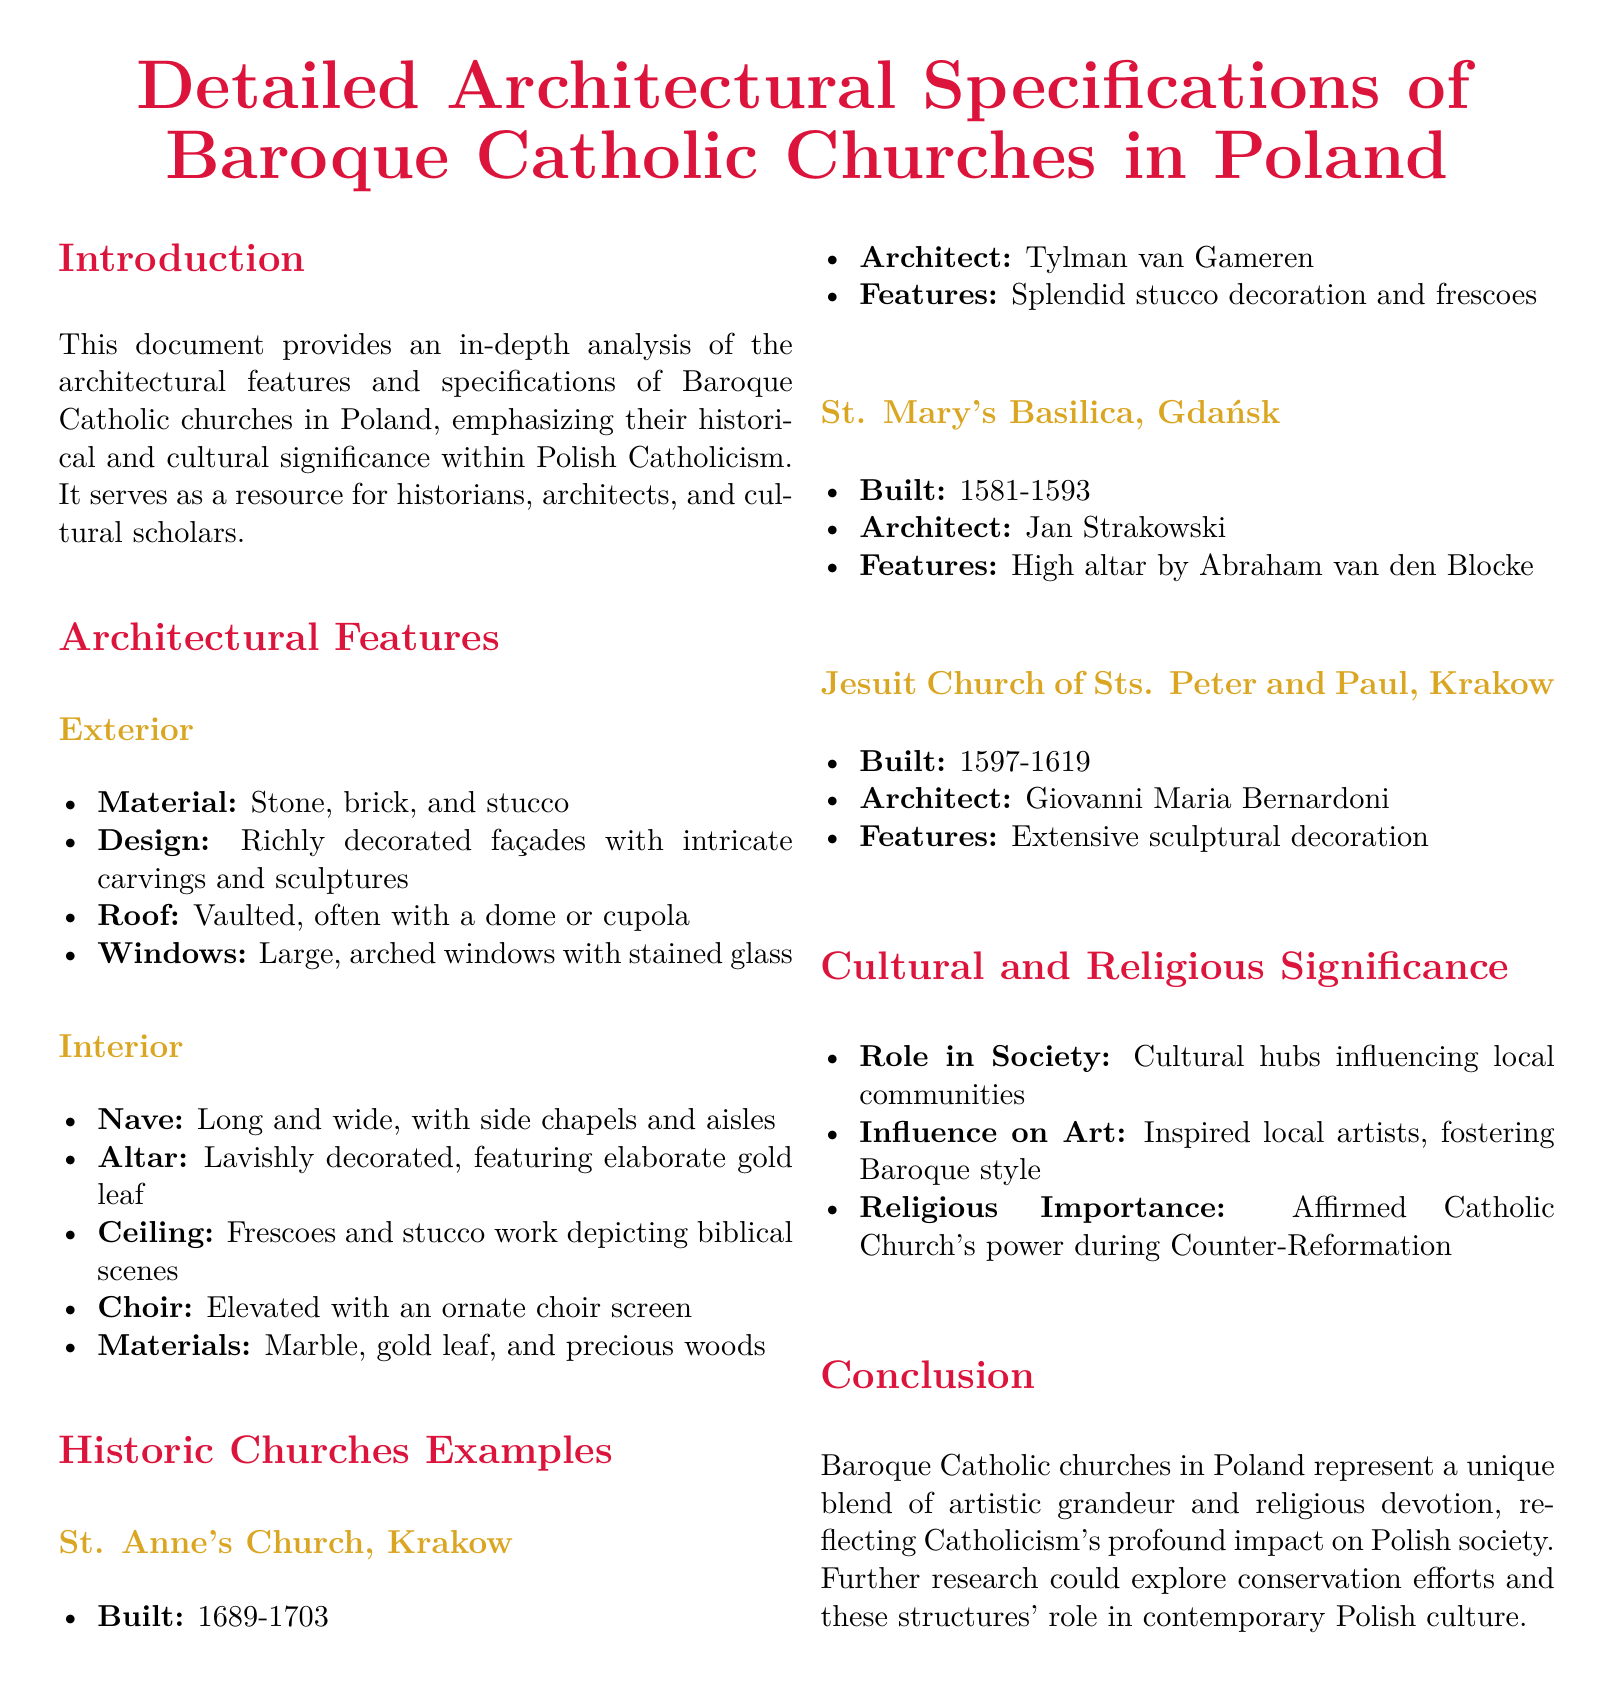What is the main subject of the document? The document focuses on the architectural specifications of Baroque Catholic churches in Poland.
Answer: Baroque Catholic churches in Poland Who is the architect of St. Anne's Church? The provided document lists Tylman van Gameren as the architect of St. Anne's Church.
Answer: Tylman van Gameren In which years was St. Mary's Basilica built? The document states that St. Mary's Basilica was built in 1581-1593.
Answer: 1581-1593 What material is primarily mentioned for the roofs of these churches? The document mentions that the roofs of the churches are vaulted, often with a dome or cupola.
Answer: Vaulted, dome or cupola What influences does the document attribute to Baroque Catholic churches? The document states that these churches influenced local artists and fostered the Baroque style.
Answer: Influenced local artists What role did these churches play in Polish society? The document identifies churches as cultural hubs influencing local communities.
Answer: Cultural hubs Which church features a high altar by Abraham van den Blocke? According to the document, St. Mary's Basilica features a high altar by Abraham van den Blocke.
Answer: St. Mary's Basilica When were the Jesuit Church of Sts. Peter and Paul constructed? The document specifies that the Jesuit Church was built from 1597 to 1619.
Answer: 1597-1619 What is a significant religious importance mentioned in the document? The document states that these churches affirmed the Catholic Church's power during the Counter-Reformation.
Answer: Affirmed Catholic Church's power during Counter-Reformation 